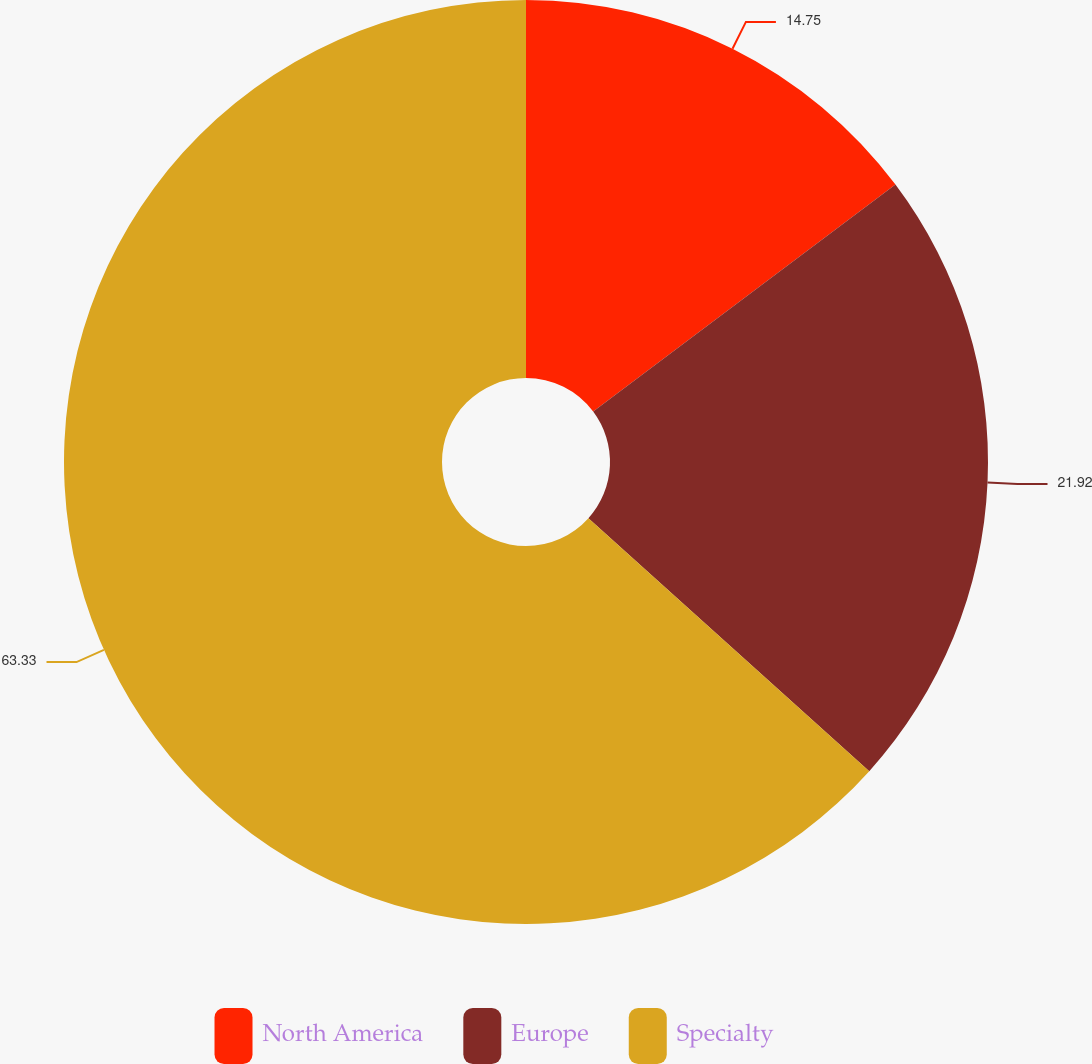Convert chart to OTSL. <chart><loc_0><loc_0><loc_500><loc_500><pie_chart><fcel>North America<fcel>Europe<fcel>Specialty<nl><fcel>14.75%<fcel>21.92%<fcel>63.33%<nl></chart> 